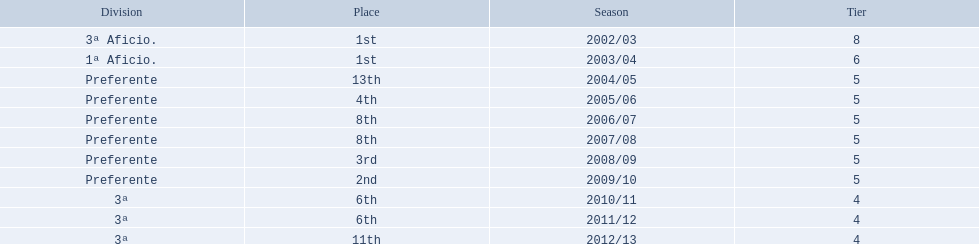Which seasons were played in tier four? 2010/11, 2011/12, 2012/13. Of these seasons, which resulted in 6th place? 2010/11, 2011/12. Which of the remaining happened last? 2011/12. 